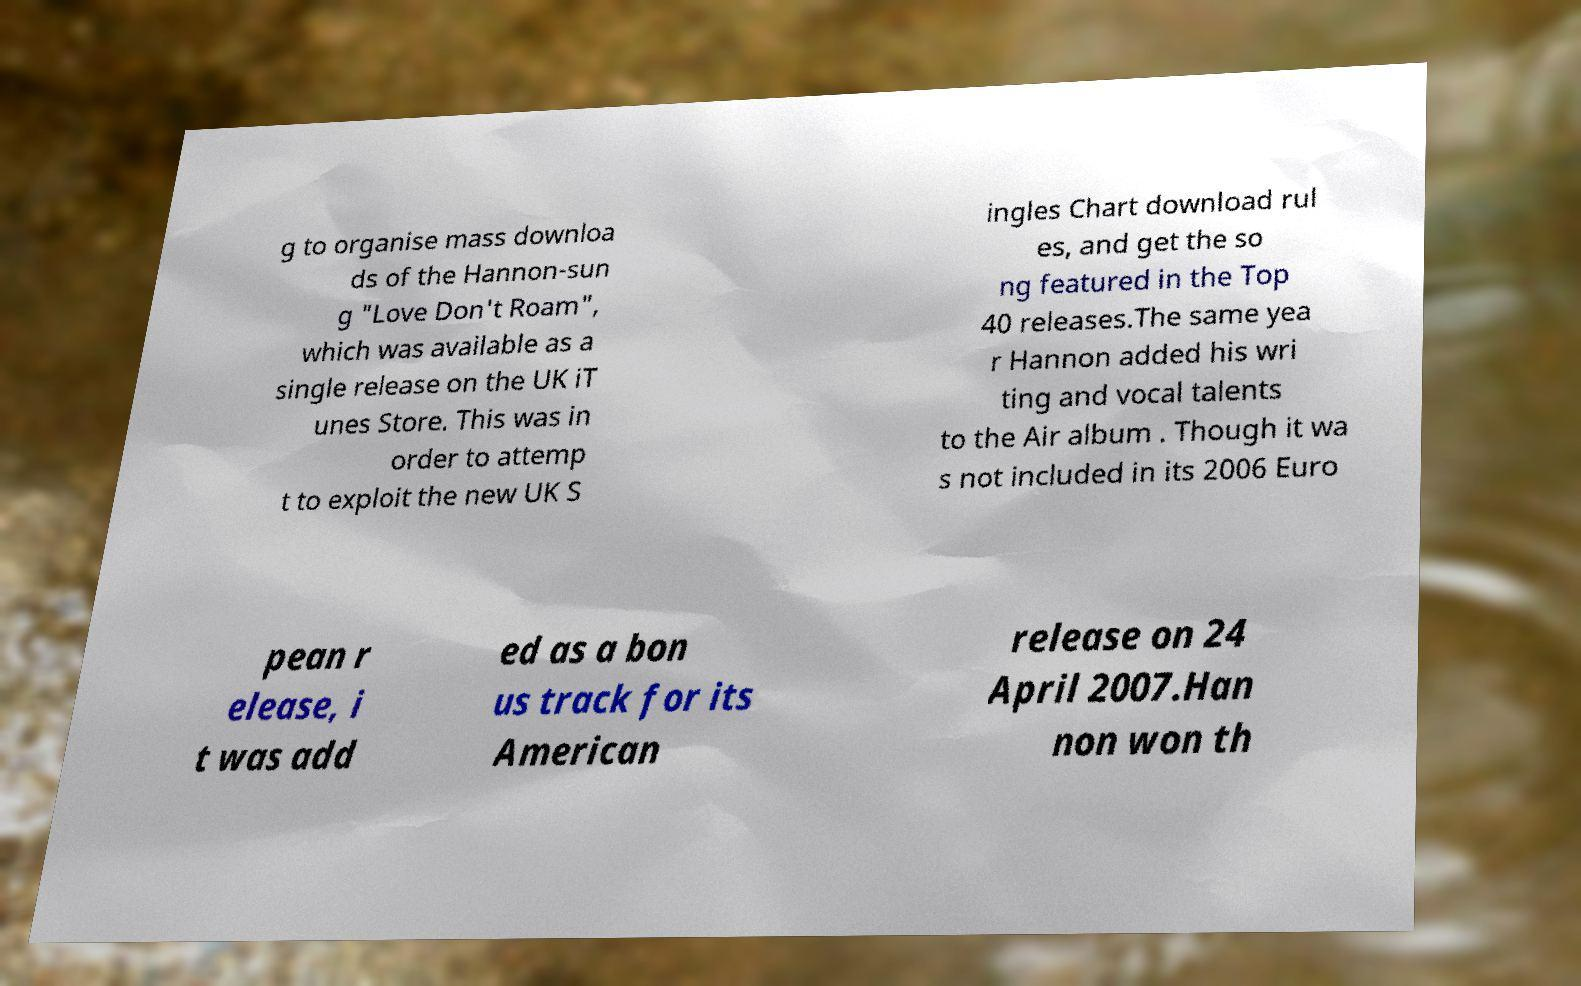Can you accurately transcribe the text from the provided image for me? g to organise mass downloa ds of the Hannon-sun g "Love Don't Roam", which was available as a single release on the UK iT unes Store. This was in order to attemp t to exploit the new UK S ingles Chart download rul es, and get the so ng featured in the Top 40 releases.The same yea r Hannon added his wri ting and vocal talents to the Air album . Though it wa s not included in its 2006 Euro pean r elease, i t was add ed as a bon us track for its American release on 24 April 2007.Han non won th 